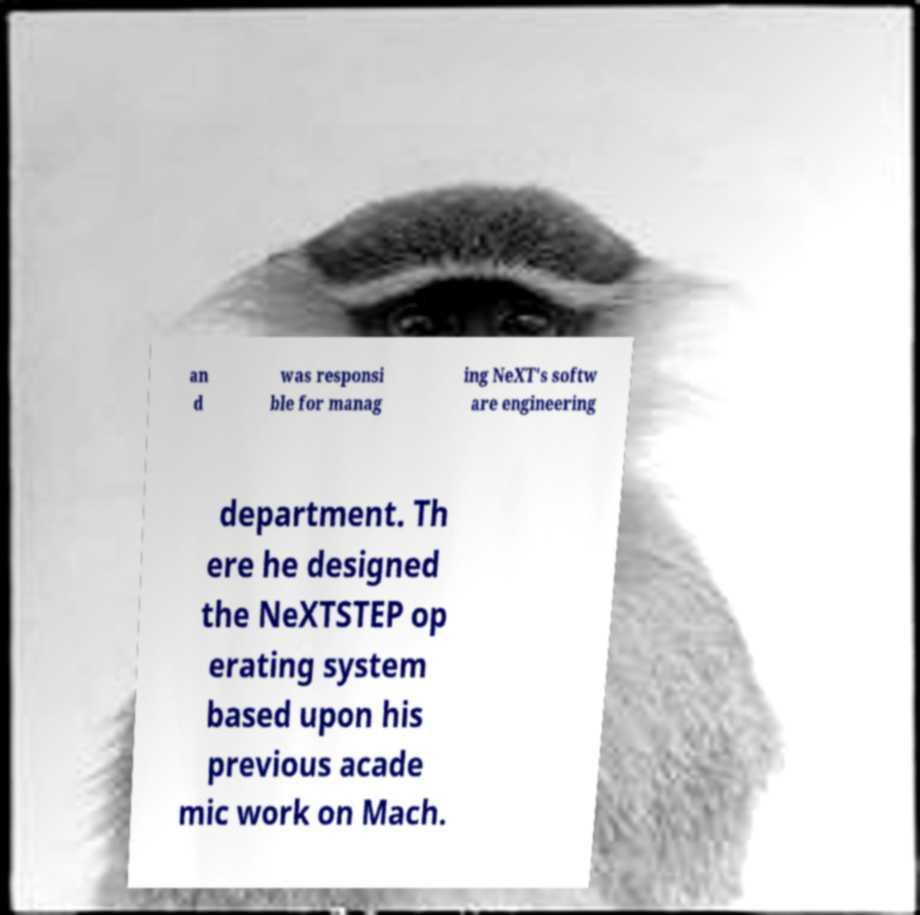Could you extract and type out the text from this image? an d was responsi ble for manag ing NeXT's softw are engineering department. Th ere he designed the NeXTSTEP op erating system based upon his previous acade mic work on Mach. 